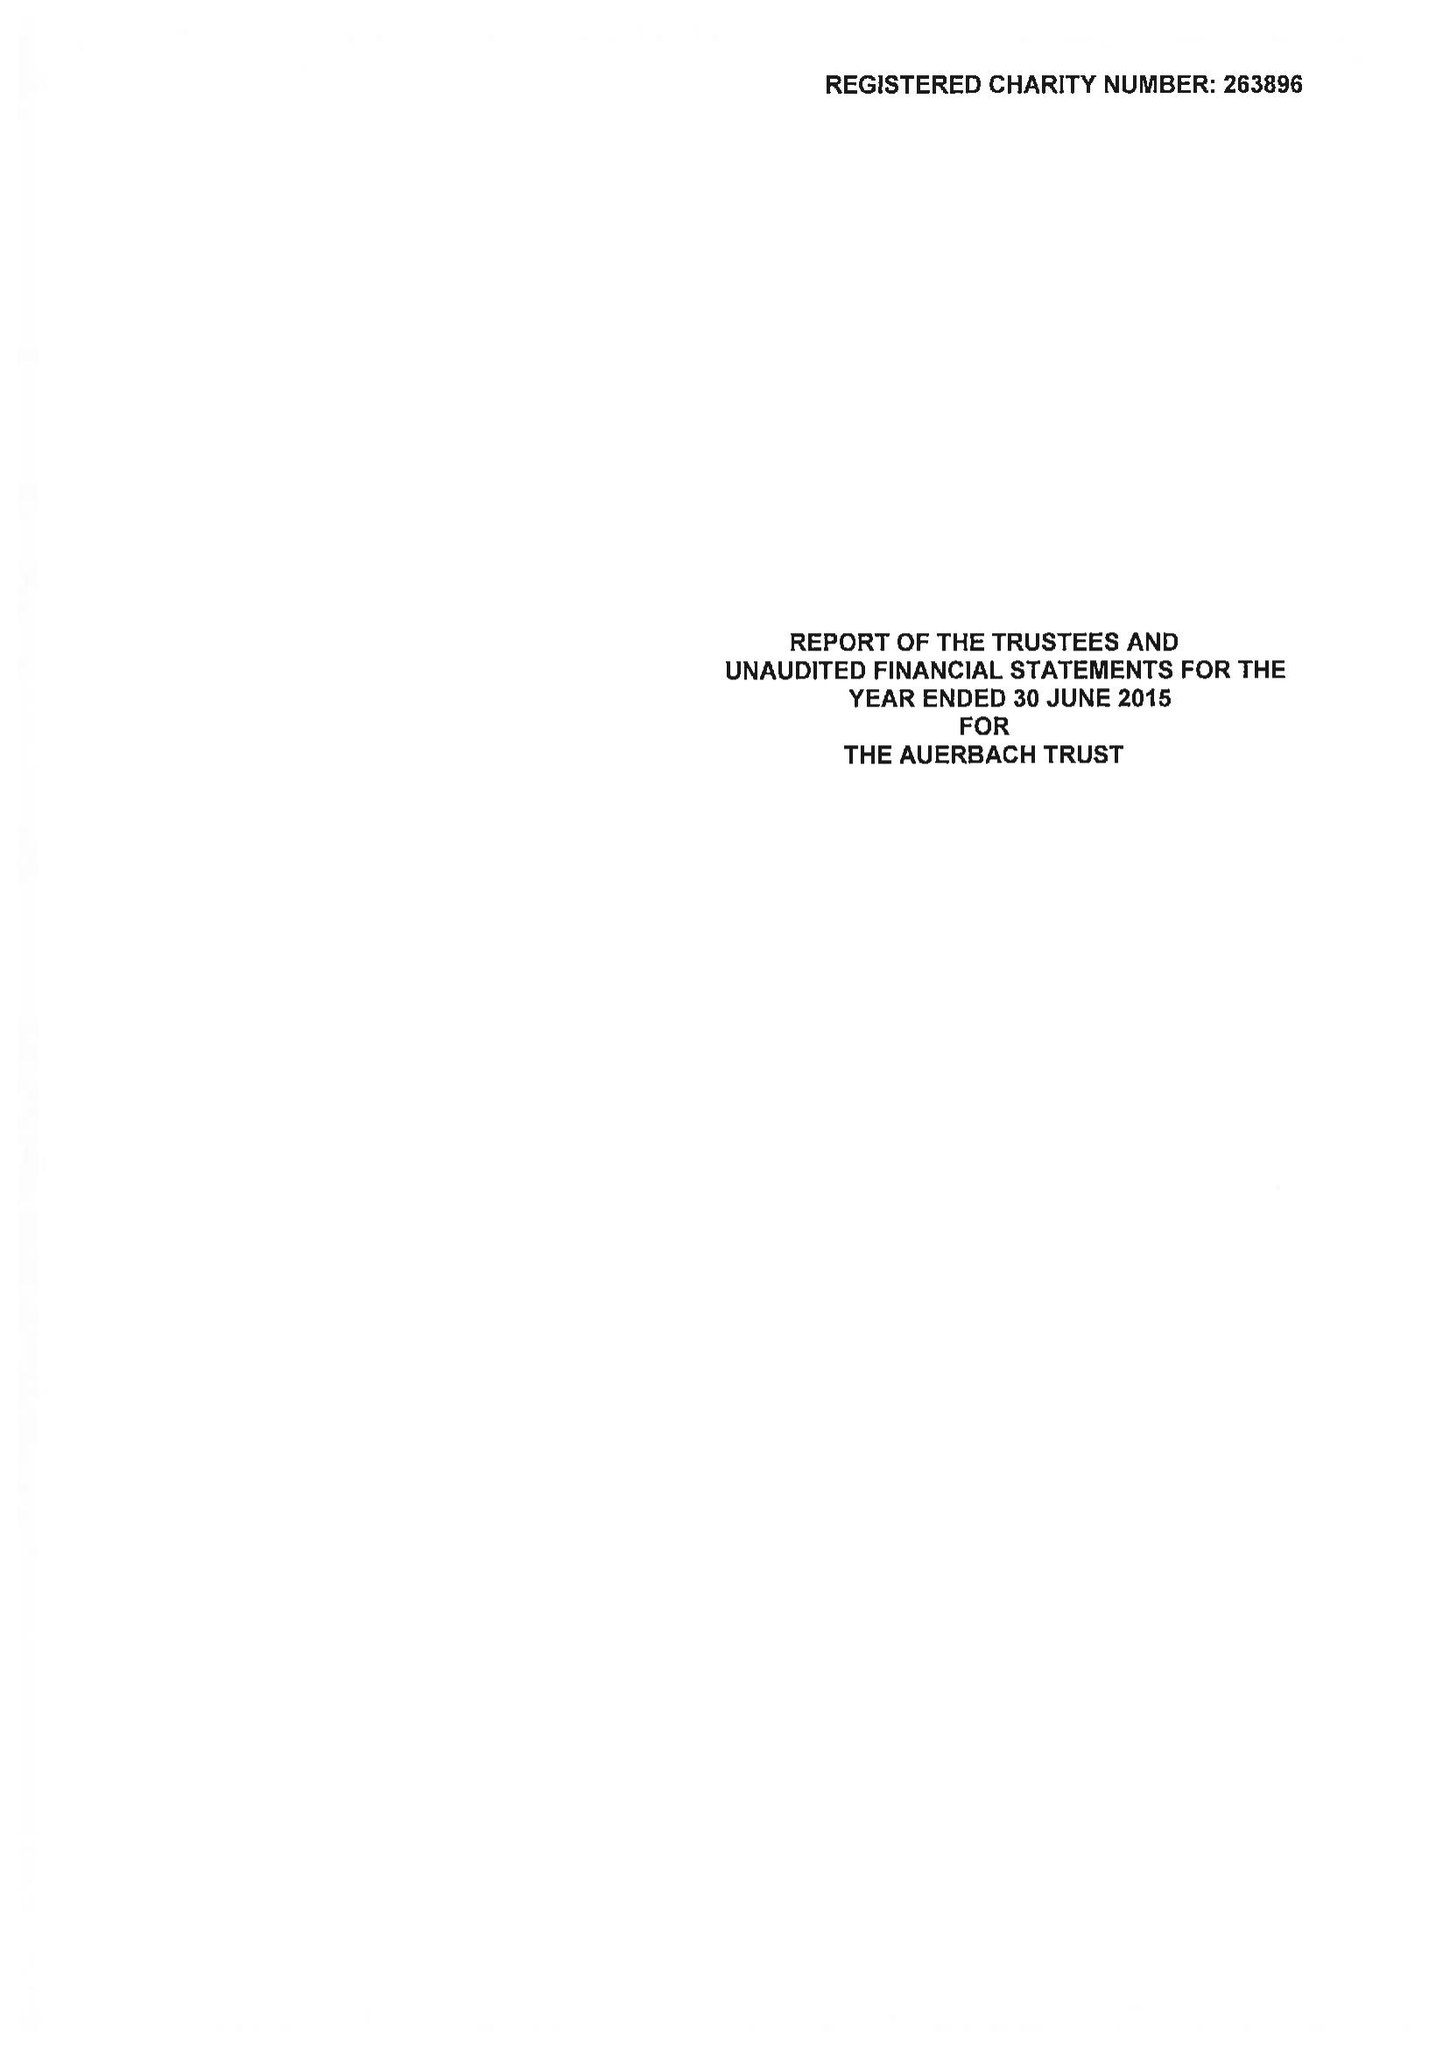What is the value for the charity_number?
Answer the question using a single word or phrase. 263896 